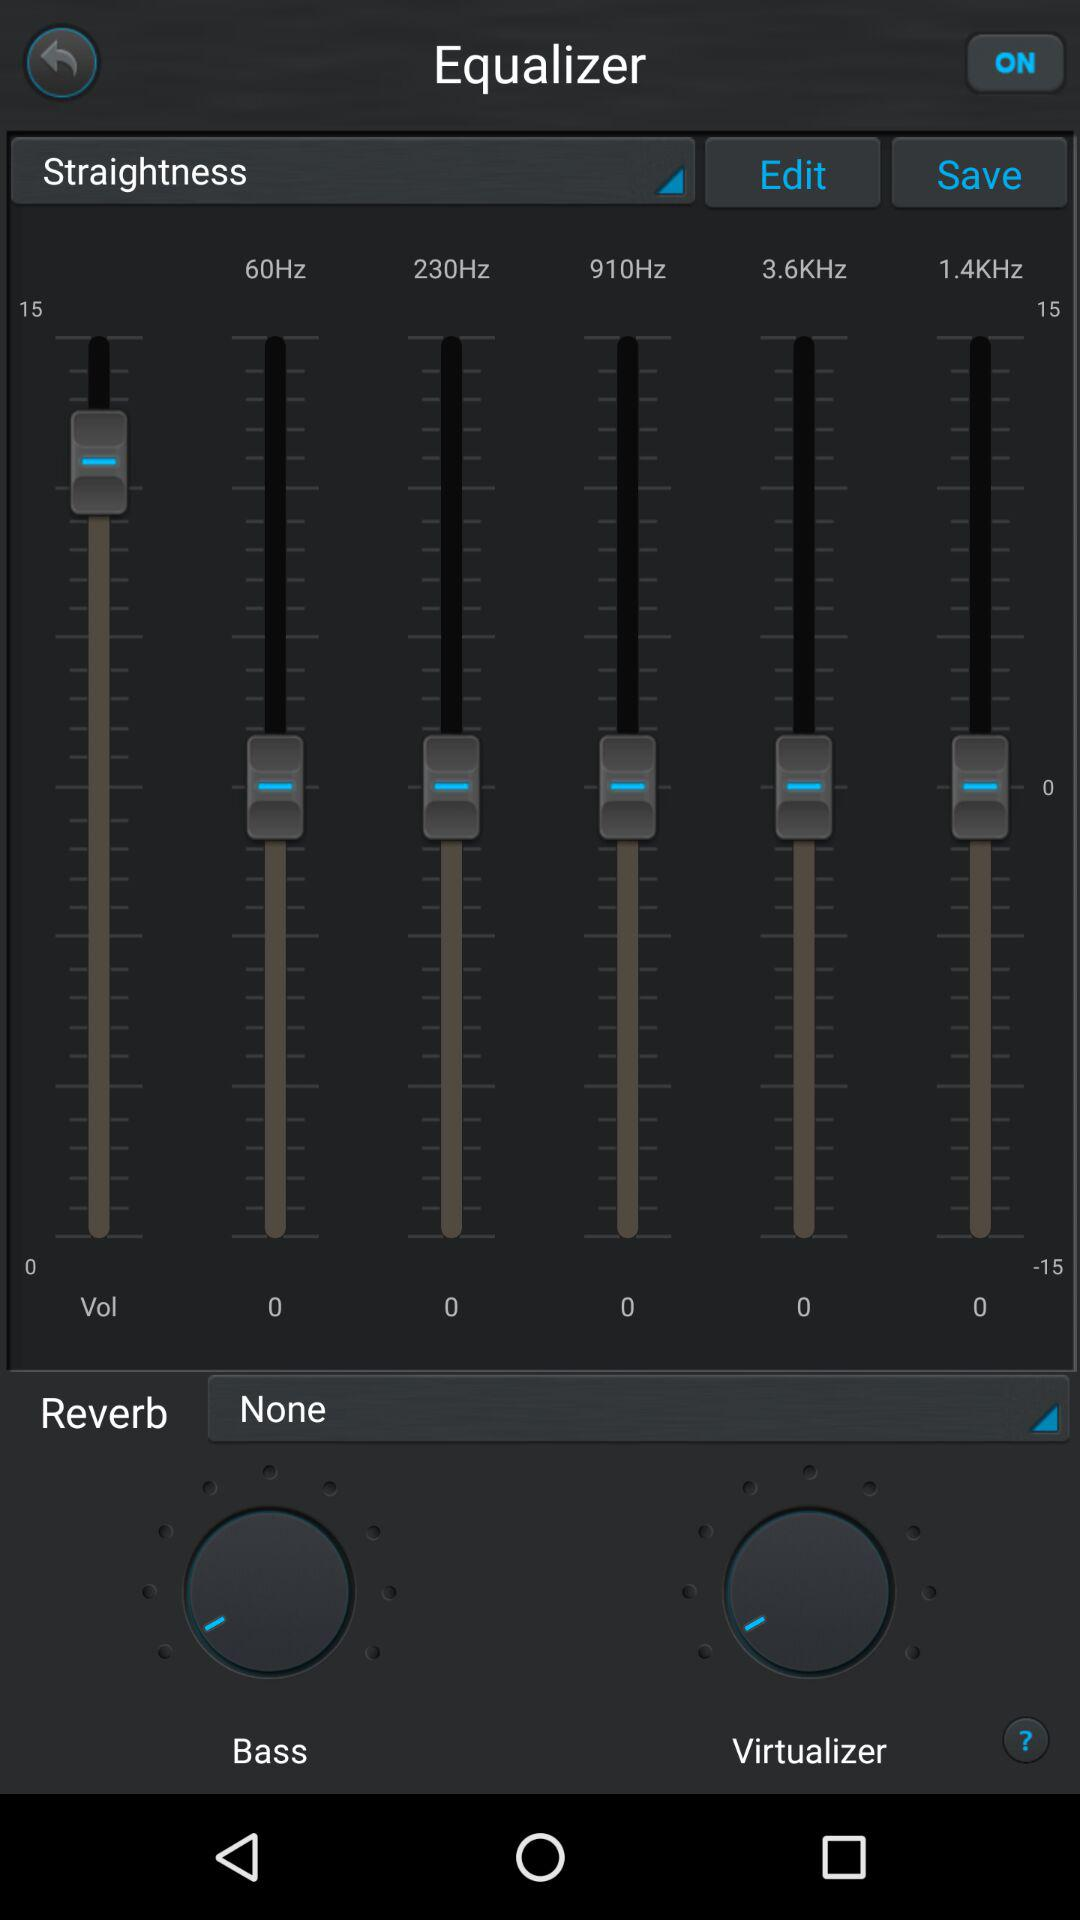Which is the selected reverb? The selected reverb is "None". 